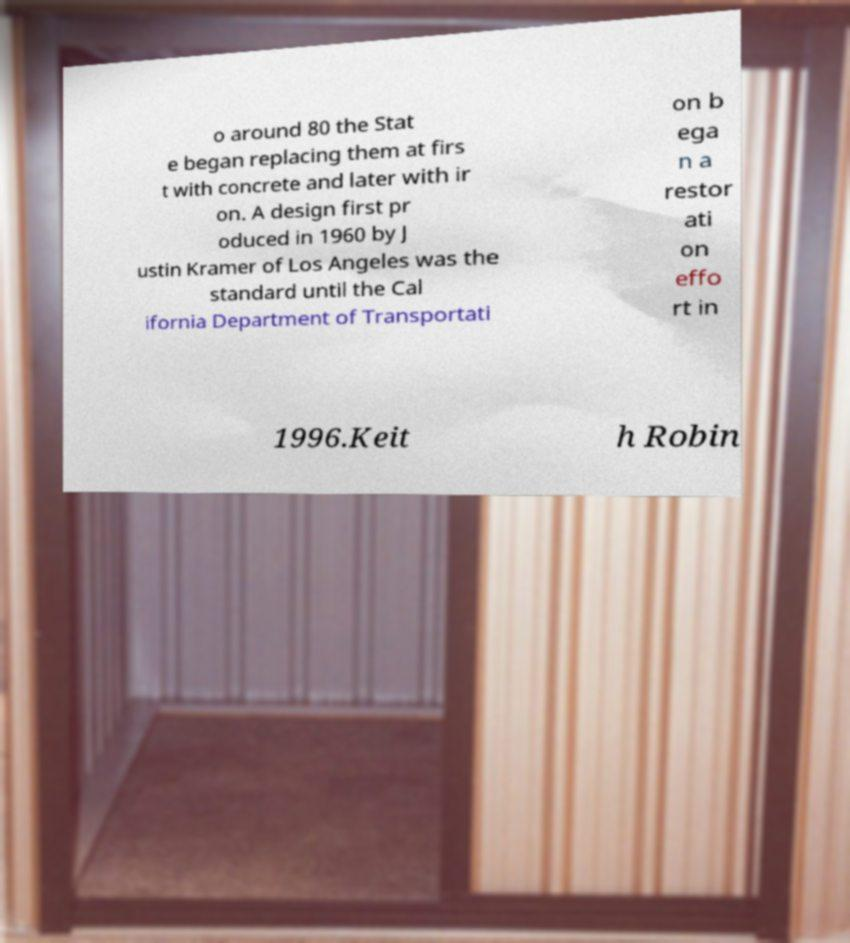There's text embedded in this image that I need extracted. Can you transcribe it verbatim? o around 80 the Stat e began replacing them at firs t with concrete and later with ir on. A design first pr oduced in 1960 by J ustin Kramer of Los Angeles was the standard until the Cal ifornia Department of Transportati on b ega n a restor ati on effo rt in 1996.Keit h Robin 